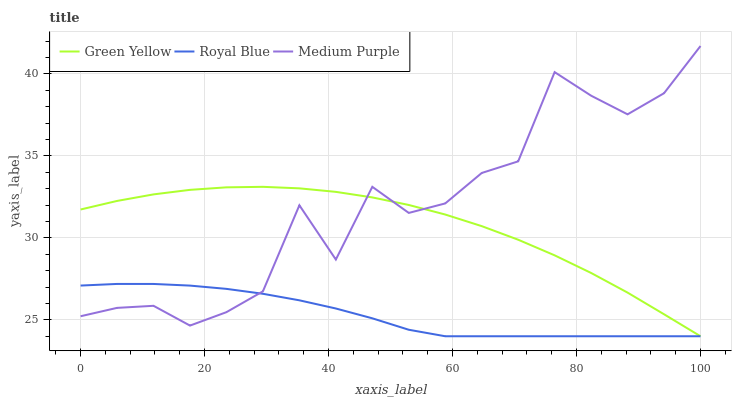Does Royal Blue have the minimum area under the curve?
Answer yes or no. Yes. Does Medium Purple have the maximum area under the curve?
Answer yes or no. Yes. Does Green Yellow have the minimum area under the curve?
Answer yes or no. No. Does Green Yellow have the maximum area under the curve?
Answer yes or no. No. Is Royal Blue the smoothest?
Answer yes or no. Yes. Is Medium Purple the roughest?
Answer yes or no. Yes. Is Green Yellow the smoothest?
Answer yes or no. No. Is Green Yellow the roughest?
Answer yes or no. No. Does Royal Blue have the lowest value?
Answer yes or no. Yes. Does Medium Purple have the highest value?
Answer yes or no. Yes. Does Green Yellow have the highest value?
Answer yes or no. No. Does Royal Blue intersect Green Yellow?
Answer yes or no. Yes. Is Royal Blue less than Green Yellow?
Answer yes or no. No. Is Royal Blue greater than Green Yellow?
Answer yes or no. No. 